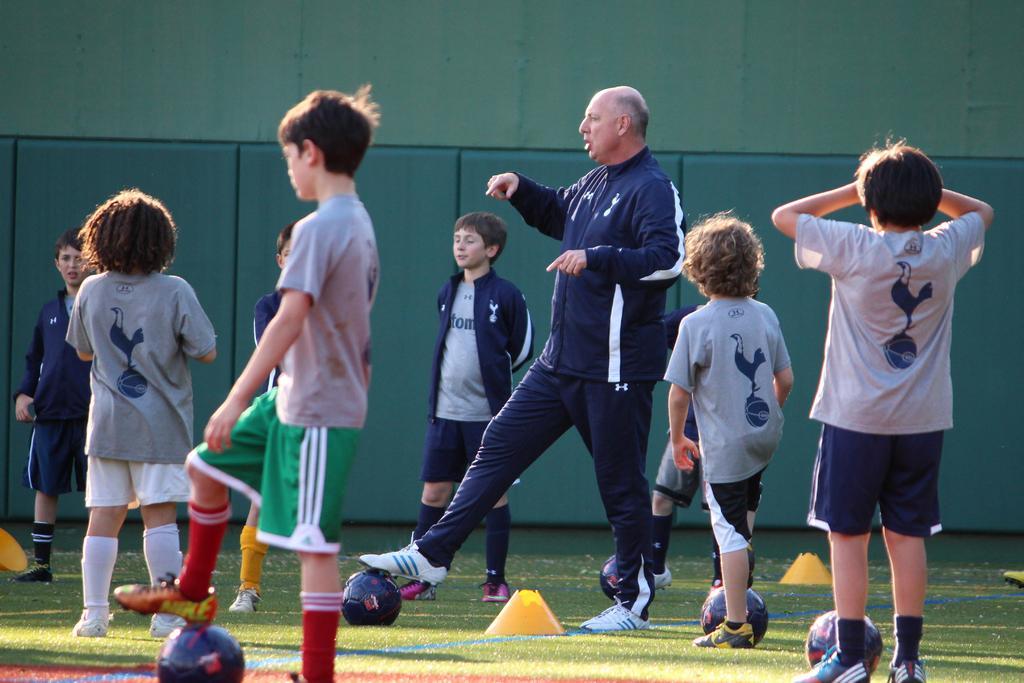Could you give a brief overview of what you see in this image? In this image there are persons standing and there is a man standing in the center and keeping his leg on the ball. In the background there is wall. On the ground there are balls and there is grass. 